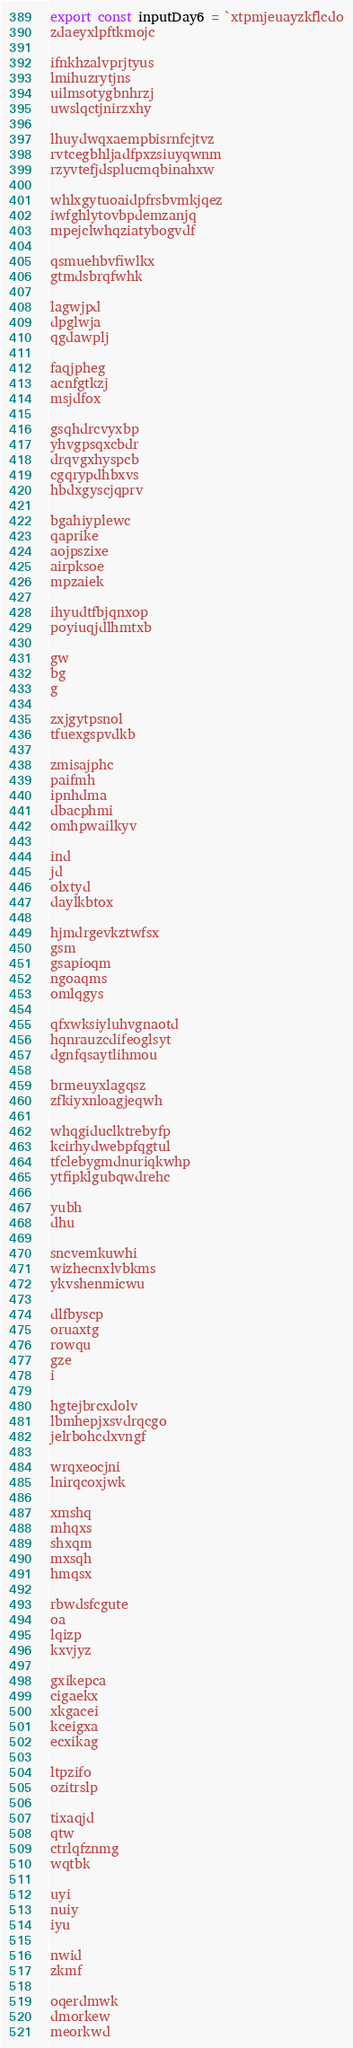<code> <loc_0><loc_0><loc_500><loc_500><_JavaScript_>export const inputDay6 = `xtpmjeuayzkflcdo
zdaeyxlpftkmojc

ifnkhzalvprjtyus
lmihuzrytjns
uilmsotygbnhrzj
uwslqctjnirzxhy

lhuydwqxaempbisrnfcjtvz
rvtcegbhljadfpxzsiuyqwnm
rzyvtefjdsplucmqbinahxw

whlxgytuoaidpfrsbvmkjqez
iwfghlytovbpdemzanjq
mpejclwhqziatybogvdf

qsmuehbvfiwlkx
gtmdsbrqfwhk

lagwjpd
dpglwja
qgdawplj

faqjpheg
acnfgtkzj
msjdfox

gsqhdrcvyxbp
yhvgpsqxcbdr
drqvgxhyspcb
cgqrypdhbxvs
hbdxgyscjqprv

bgahiyplewc
qaprike
aojpszixe
airpksoe
mpzaiek

ihyudtfbjqnxop
poyiuqjdlhmtxb

gw
bg
g

zxjgytpsnol
tfuexgspvdkb

zmisajphc
paifmh
ipnhdma
dbacphmi
omhpwailkyv

ind
jd
olxtyd
daylkbtox

hjmdrgevkztwfsx
gsm
gsapioqm
ngoaqms
omlqgys

qfxwksiyluhvgnaotd
hqnrauzcdifeoglsyt
dgnfqsaytlihmou

brmeuyxlagqsz
zfkiyxnloagjeqwh

whqgiduclktrebyfp
kcirhydwebpfqgtul
tfclebygmdnuriqkwhp
ytfipklgubqwdrehc

yubh
dhu

sncvemkuwhi
wizhecnxlvbkms
ykvshenmicwu

dlfbyscp
oruaxtg
rowqu
gze
i

hgtejbrcxdolv
lbmhepjxsvdrqcgo
jelrbohcdxvngf

wrqxeocjni
lnirqcoxjwk

xmshq
mhqxs
shxqm
mxsqh
hmqsx

rbwdsfcgute
oa
lqizp
kxvjyz

gxikepca
cigaekx
xkgacei
kceigxa
ecxikag

ltpzifo
ozitrslp

tixaqjd
qtw
ctrlqfznmg
wqtbk

uyi
nuiy
iyu

nwid
zkmf

oqerdmwk
dmorkew
meorkwd
</code> 